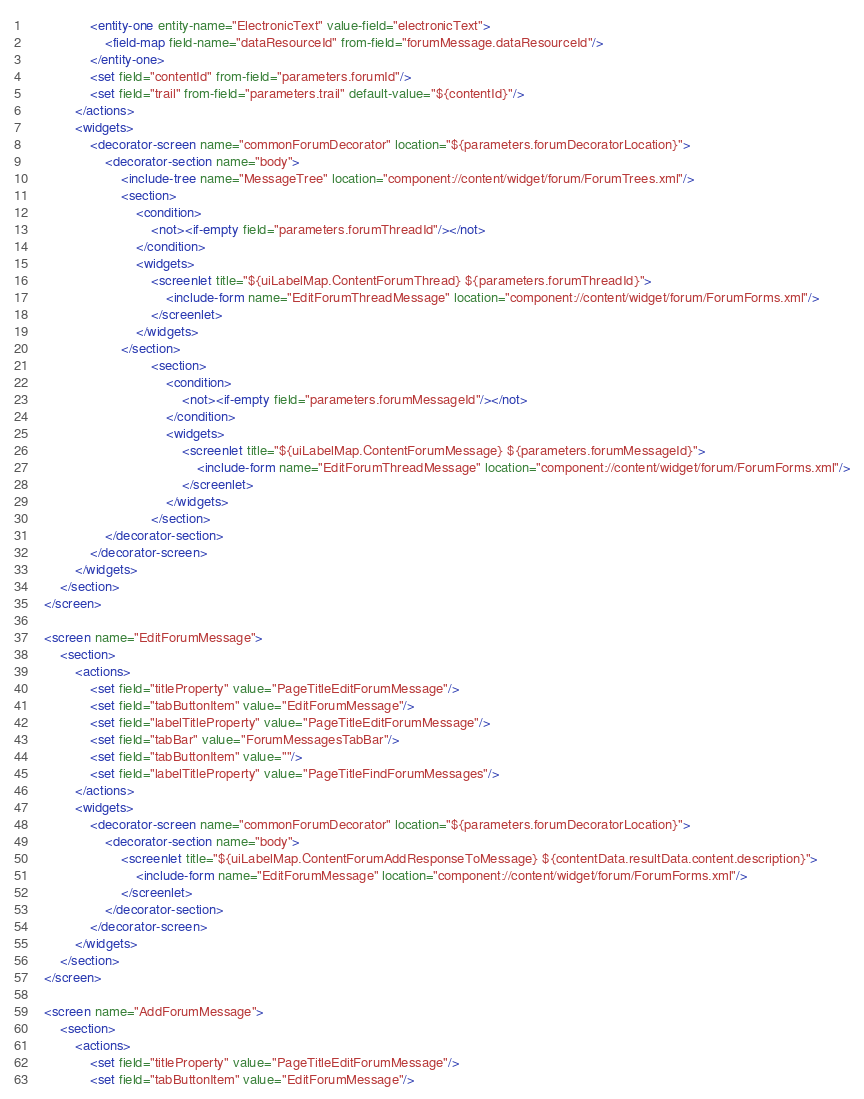Convert code to text. <code><loc_0><loc_0><loc_500><loc_500><_XML_>                <entity-one entity-name="ElectronicText" value-field="electronicText">
                    <field-map field-name="dataResourceId" from-field="forumMessage.dataResourceId"/>
                </entity-one>
                <set field="contentId" from-field="parameters.forumId"/>
                <set field="trail" from-field="parameters.trail" default-value="${contentId}"/>
            </actions>
            <widgets>
                <decorator-screen name="commonForumDecorator" location="${parameters.forumDecoratorLocation}">
                    <decorator-section name="body">
                        <include-tree name="MessageTree" location="component://content/widget/forum/ForumTrees.xml"/>
                        <section>
                            <condition>
                                <not><if-empty field="parameters.forumThreadId"/></not>
                            </condition>
                            <widgets>
                                <screenlet title="${uiLabelMap.ContentForumThread} ${parameters.forumThreadId}">
                                    <include-form name="EditForumThreadMessage" location="component://content/widget/forum/ForumForms.xml"/>
                                </screenlet>
                            </widgets>
                        </section>
                                <section>
                                    <condition>
                                        <not><if-empty field="parameters.forumMessageId"/></not>
                                    </condition>
                                    <widgets>
                                        <screenlet title="${uiLabelMap.ContentForumMessage} ${parameters.forumMessageId}">
                                            <include-form name="EditForumThreadMessage" location="component://content/widget/forum/ForumForms.xml"/>
                                        </screenlet>
                                    </widgets>
                                </section>
                    </decorator-section>
                </decorator-screen>
            </widgets>
        </section>
    </screen>

    <screen name="EditForumMessage">
        <section>
            <actions>
                <set field="titleProperty" value="PageTitleEditForumMessage"/>
                <set field="tabButtonItem" value="EditForumMessage"/>
                <set field="labelTitleProperty" value="PageTitleEditForumMessage"/>
                <set field="tabBar" value="ForumMessagesTabBar"/>
                <set field="tabButtonItem" value=""/>
                <set field="labelTitleProperty" value="PageTitleFindForumMessages"/>
            </actions>
            <widgets>
                <decorator-screen name="commonForumDecorator" location="${parameters.forumDecoratorLocation}">
                    <decorator-section name="body">
                        <screenlet title="${uiLabelMap.ContentForumAddResponseToMessage} ${contentData.resultData.content.description}">
                            <include-form name="EditForumMessage" location="component://content/widget/forum/ForumForms.xml"/>
                        </screenlet>
                    </decorator-section>
                </decorator-screen>
            </widgets>
        </section>
    </screen>

    <screen name="AddForumMessage">
        <section>
            <actions>
                <set field="titleProperty" value="PageTitleEditForumMessage"/>
                <set field="tabButtonItem" value="EditForumMessage"/></code> 